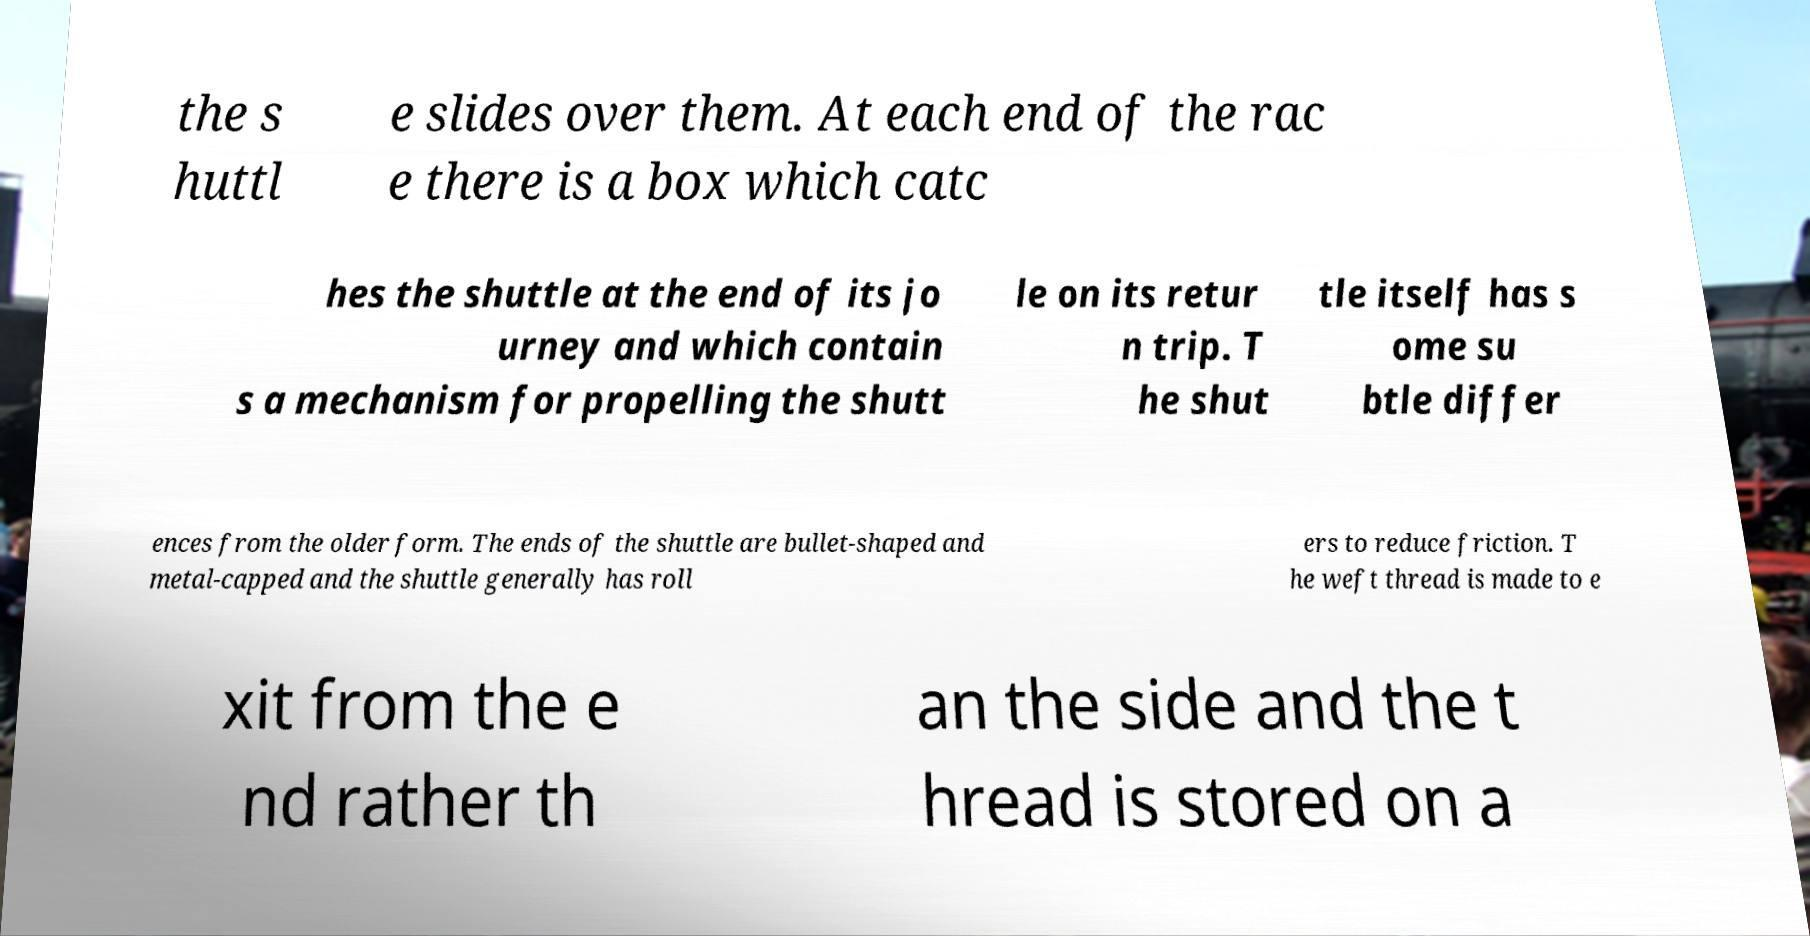Please read and relay the text visible in this image. What does it say? the s huttl e slides over them. At each end of the rac e there is a box which catc hes the shuttle at the end of its jo urney and which contain s a mechanism for propelling the shutt le on its retur n trip. T he shut tle itself has s ome su btle differ ences from the older form. The ends of the shuttle are bullet-shaped and metal-capped and the shuttle generally has roll ers to reduce friction. T he weft thread is made to e xit from the e nd rather th an the side and the t hread is stored on a 